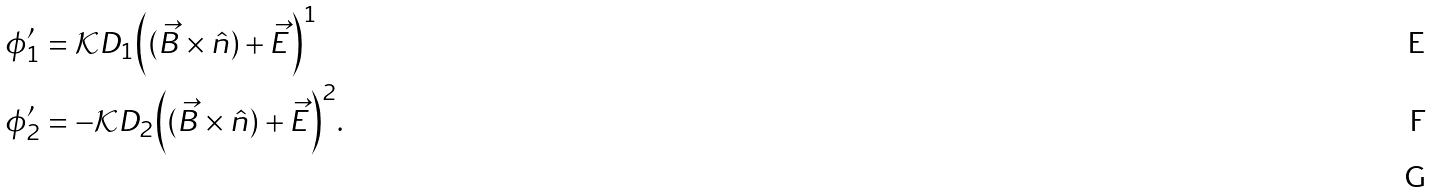<formula> <loc_0><loc_0><loc_500><loc_500>\phi ^ { \prime } _ { 1 } & = \mathcal { K } D _ { 1 } \Big { ( } ( \vec { B } \times \hat { n } ) + \vec { E } \Big { ) } ^ { 1 } \\ \phi ^ { \prime } _ { 2 } & = - \mathcal { K } D _ { 2 } \Big { ( } ( \vec { B } \times \hat { n } ) + \vec { E } \Big { ) } ^ { 2 } . \\</formula> 